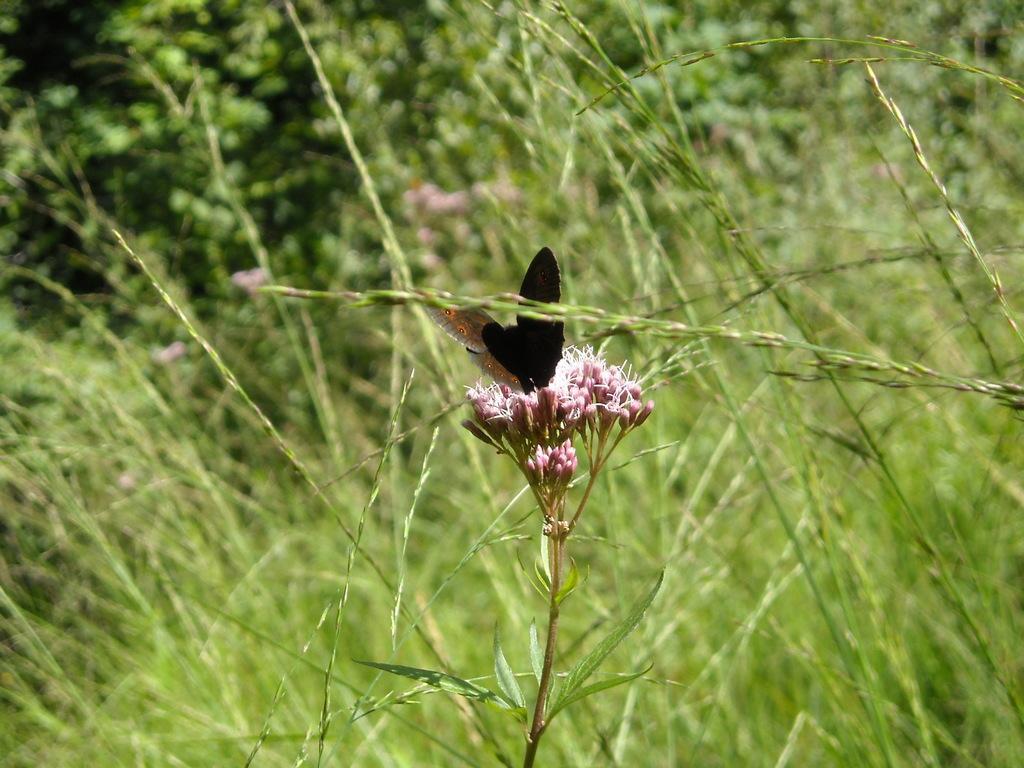How would you summarize this image in a sentence or two? In this image we can see a plant with buds and a butterfly on it and grass and plants in the background. 